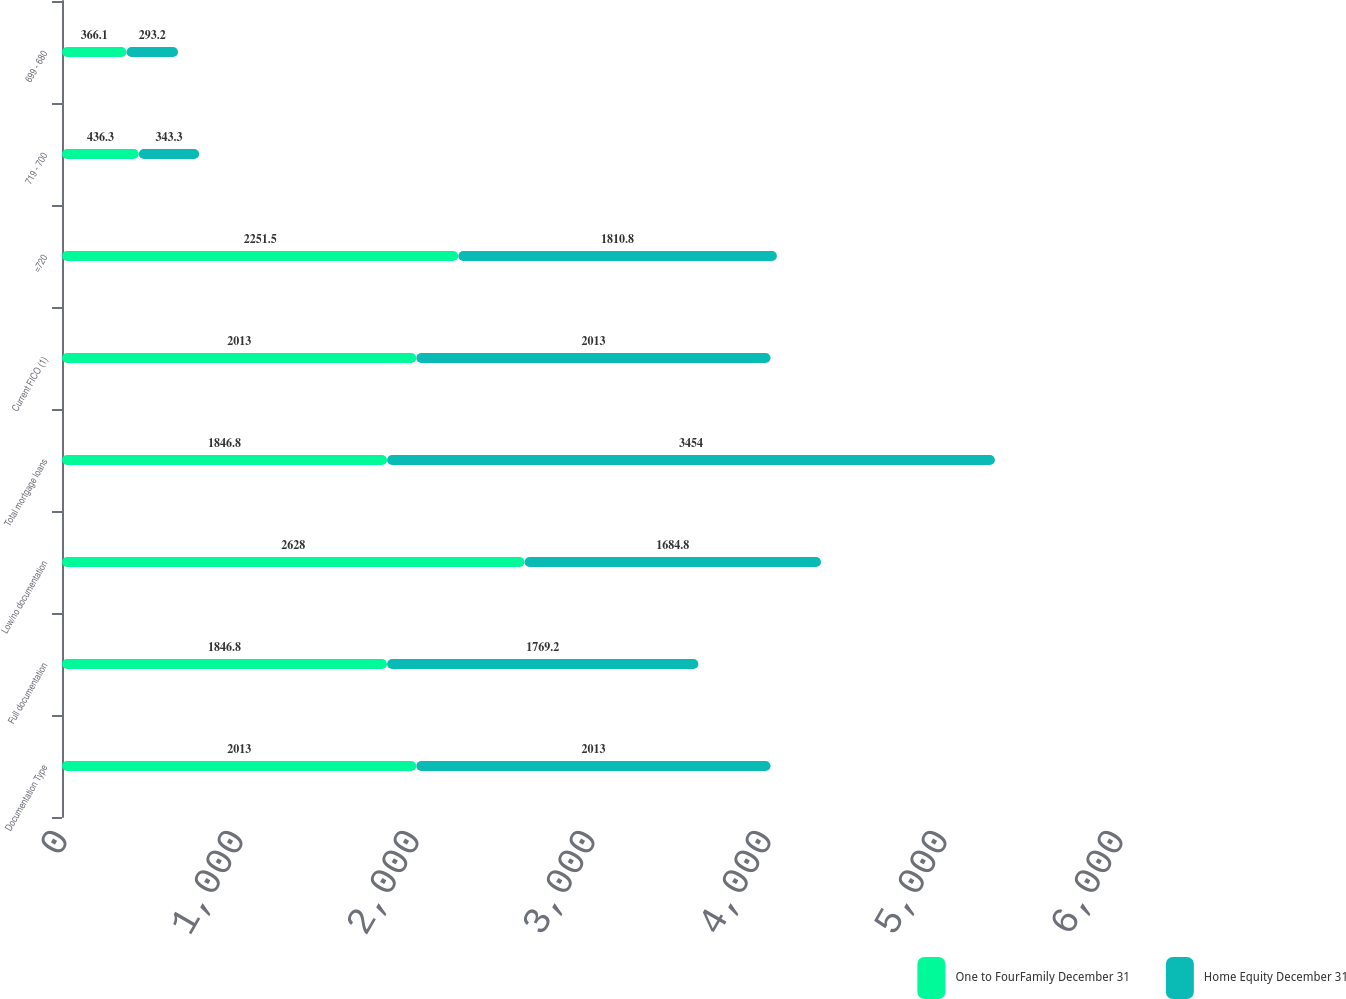Convert chart. <chart><loc_0><loc_0><loc_500><loc_500><stacked_bar_chart><ecel><fcel>Documentation Type<fcel>Full documentation<fcel>Low/no documentation<fcel>Total mortgage loans<fcel>Current FICO (1)<fcel>=720<fcel>719 - 700<fcel>699 - 680<nl><fcel>One to FourFamily December 31<fcel>2013<fcel>1846.8<fcel>2628<fcel>1846.8<fcel>2013<fcel>2251.5<fcel>436.3<fcel>366.1<nl><fcel>Home Equity December 31<fcel>2013<fcel>1769.2<fcel>1684.8<fcel>3454<fcel>2013<fcel>1810.8<fcel>343.3<fcel>293.2<nl></chart> 